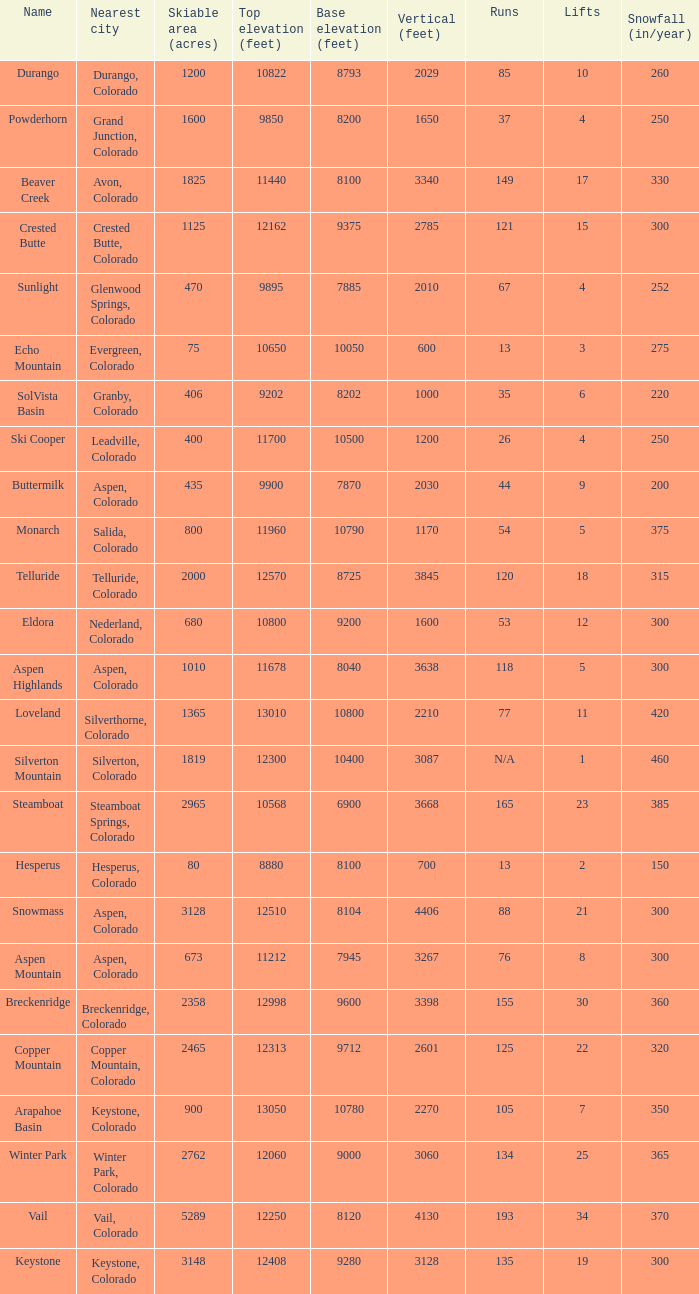How many resorts have 118 runs? 1.0. 